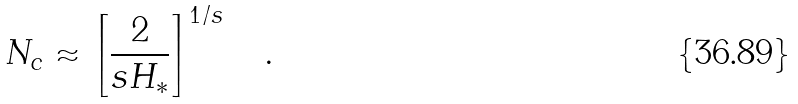Convert formula to latex. <formula><loc_0><loc_0><loc_500><loc_500>N _ { c } \approx \left [ \frac { 2 } { s H _ { * } } \right ] ^ { 1 / s } \quad .</formula> 